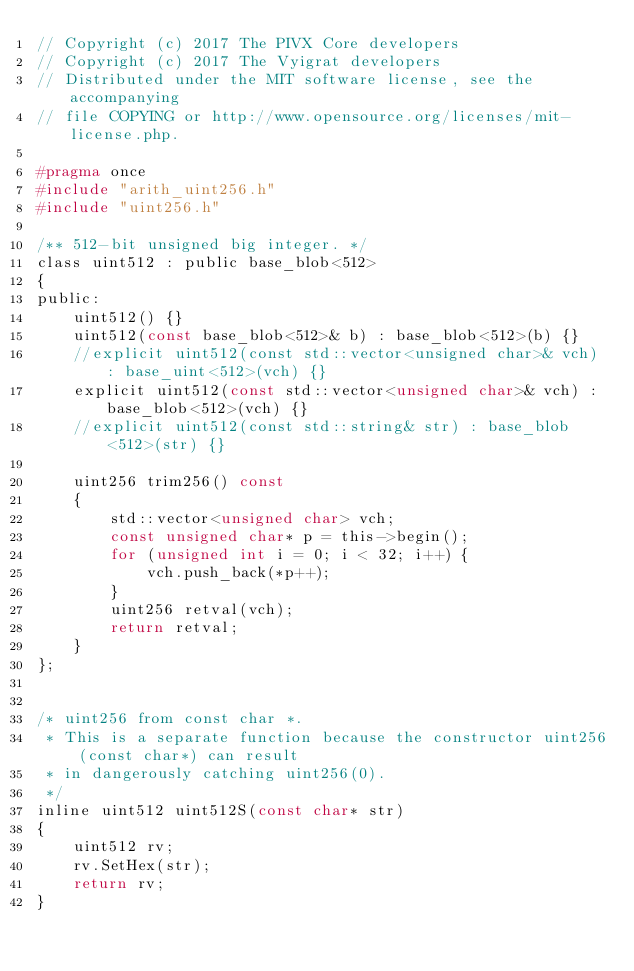Convert code to text. <code><loc_0><loc_0><loc_500><loc_500><_C_>// Copyright (c) 2017 The PIVX Core developers
// Copyright (c) 2017 The Vyigrat developers
// Distributed under the MIT software license, see the accompanying
// file COPYING or http://www.opensource.org/licenses/mit-license.php.

#pragma once
#include "arith_uint256.h"
#include "uint256.h"

/** 512-bit unsigned big integer. */
class uint512 : public base_blob<512>
{
public:
    uint512() {}
    uint512(const base_blob<512>& b) : base_blob<512>(b) {}
    //explicit uint512(const std::vector<unsigned char>& vch) : base_uint<512>(vch) {}
    explicit uint512(const std::vector<unsigned char>& vch) : base_blob<512>(vch) {}
    //explicit uint512(const std::string& str) : base_blob<512>(str) {}

    uint256 trim256() const
    {
        std::vector<unsigned char> vch;
        const unsigned char* p = this->begin();
        for (unsigned int i = 0; i < 32; i++) {
            vch.push_back(*p++);
        }
        uint256 retval(vch);
        return retval;
    }
};


/* uint256 from const char *.
 * This is a separate function because the constructor uint256(const char*) can result
 * in dangerously catching uint256(0).
 */
inline uint512 uint512S(const char* str)
{
    uint512 rv;
    rv.SetHex(str);
    return rv;
}
</code> 